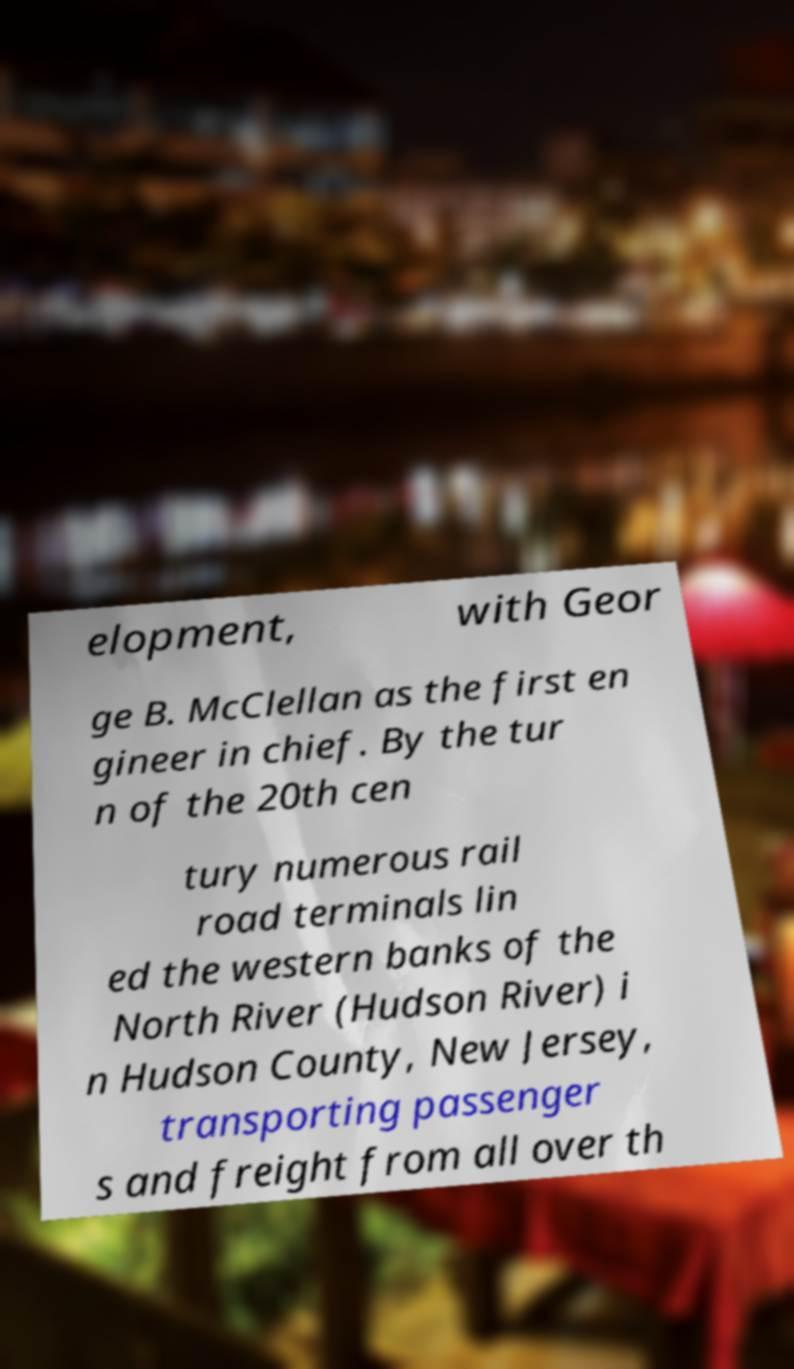Could you extract and type out the text from this image? elopment, with Geor ge B. McClellan as the first en gineer in chief. By the tur n of the 20th cen tury numerous rail road terminals lin ed the western banks of the North River (Hudson River) i n Hudson County, New Jersey, transporting passenger s and freight from all over th 